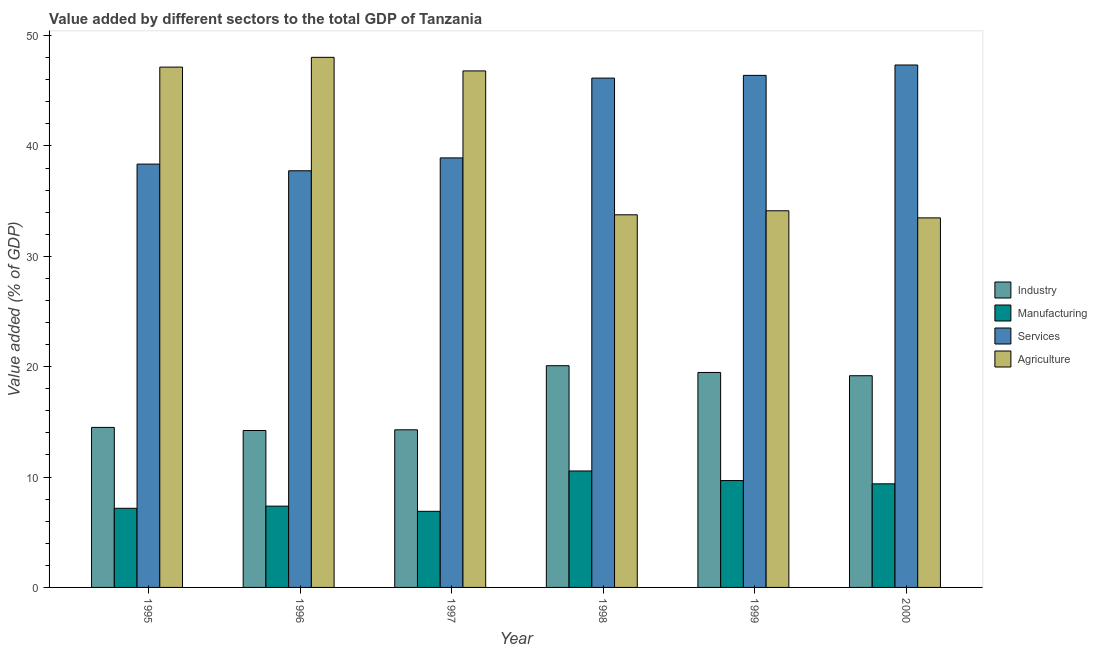How many bars are there on the 3rd tick from the left?
Your response must be concise. 4. What is the label of the 5th group of bars from the left?
Your answer should be very brief. 1999. What is the value added by industrial sector in 1999?
Your answer should be compact. 19.48. Across all years, what is the maximum value added by manufacturing sector?
Keep it short and to the point. 10.55. Across all years, what is the minimum value added by manufacturing sector?
Your answer should be compact. 6.9. In which year was the value added by industrial sector maximum?
Keep it short and to the point. 1998. In which year was the value added by services sector minimum?
Your response must be concise. 1996. What is the total value added by industrial sector in the graph?
Keep it short and to the point. 101.75. What is the difference between the value added by manufacturing sector in 1998 and that in 1999?
Provide a short and direct response. 0.87. What is the difference between the value added by services sector in 1995 and the value added by manufacturing sector in 1997?
Your response must be concise. -0.56. What is the average value added by agricultural sector per year?
Your answer should be very brief. 40.56. In the year 1999, what is the difference between the value added by services sector and value added by manufacturing sector?
Your answer should be compact. 0. In how many years, is the value added by services sector greater than 34 %?
Give a very brief answer. 6. What is the ratio of the value added by agricultural sector in 1999 to that in 2000?
Provide a succinct answer. 1.02. Is the value added by manufacturing sector in 1998 less than that in 2000?
Provide a succinct answer. No. Is the difference between the value added by manufacturing sector in 1998 and 2000 greater than the difference between the value added by services sector in 1998 and 2000?
Your response must be concise. No. What is the difference between the highest and the second highest value added by services sector?
Provide a succinct answer. 0.94. What is the difference between the highest and the lowest value added by services sector?
Provide a succinct answer. 9.58. Is the sum of the value added by manufacturing sector in 1997 and 1999 greater than the maximum value added by industrial sector across all years?
Make the answer very short. Yes. What does the 3rd bar from the left in 1999 represents?
Offer a terse response. Services. What does the 3rd bar from the right in 2000 represents?
Offer a terse response. Manufacturing. Is it the case that in every year, the sum of the value added by industrial sector and value added by manufacturing sector is greater than the value added by services sector?
Offer a very short reply. No. Are the values on the major ticks of Y-axis written in scientific E-notation?
Your response must be concise. No. Does the graph contain any zero values?
Your answer should be very brief. No. How many legend labels are there?
Provide a succinct answer. 4. What is the title of the graph?
Make the answer very short. Value added by different sectors to the total GDP of Tanzania. What is the label or title of the Y-axis?
Provide a succinct answer. Value added (% of GDP). What is the Value added (% of GDP) in Industry in 1995?
Offer a terse response. 14.5. What is the Value added (% of GDP) in Manufacturing in 1995?
Ensure brevity in your answer.  7.17. What is the Value added (% of GDP) of Services in 1995?
Your answer should be compact. 38.36. What is the Value added (% of GDP) in Agriculture in 1995?
Provide a short and direct response. 47.14. What is the Value added (% of GDP) of Industry in 1996?
Your answer should be very brief. 14.22. What is the Value added (% of GDP) in Manufacturing in 1996?
Your response must be concise. 7.37. What is the Value added (% of GDP) of Services in 1996?
Keep it short and to the point. 37.75. What is the Value added (% of GDP) of Agriculture in 1996?
Your answer should be compact. 48.03. What is the Value added (% of GDP) in Industry in 1997?
Your response must be concise. 14.28. What is the Value added (% of GDP) of Manufacturing in 1997?
Your answer should be very brief. 6.9. What is the Value added (% of GDP) in Services in 1997?
Ensure brevity in your answer.  38.92. What is the Value added (% of GDP) in Agriculture in 1997?
Provide a short and direct response. 46.8. What is the Value added (% of GDP) of Industry in 1998?
Make the answer very short. 20.09. What is the Value added (% of GDP) in Manufacturing in 1998?
Provide a short and direct response. 10.55. What is the Value added (% of GDP) in Services in 1998?
Keep it short and to the point. 46.15. What is the Value added (% of GDP) of Agriculture in 1998?
Provide a succinct answer. 33.76. What is the Value added (% of GDP) of Industry in 1999?
Provide a short and direct response. 19.48. What is the Value added (% of GDP) of Manufacturing in 1999?
Offer a very short reply. 9.68. What is the Value added (% of GDP) of Services in 1999?
Offer a terse response. 46.39. What is the Value added (% of GDP) of Agriculture in 1999?
Offer a very short reply. 34.13. What is the Value added (% of GDP) of Industry in 2000?
Offer a very short reply. 19.18. What is the Value added (% of GDP) in Manufacturing in 2000?
Ensure brevity in your answer.  9.39. What is the Value added (% of GDP) of Services in 2000?
Offer a very short reply. 47.34. What is the Value added (% of GDP) of Agriculture in 2000?
Offer a very short reply. 33.48. Across all years, what is the maximum Value added (% of GDP) of Industry?
Ensure brevity in your answer.  20.09. Across all years, what is the maximum Value added (% of GDP) of Manufacturing?
Give a very brief answer. 10.55. Across all years, what is the maximum Value added (% of GDP) of Services?
Your response must be concise. 47.34. Across all years, what is the maximum Value added (% of GDP) of Agriculture?
Keep it short and to the point. 48.03. Across all years, what is the minimum Value added (% of GDP) in Industry?
Provide a short and direct response. 14.22. Across all years, what is the minimum Value added (% of GDP) in Manufacturing?
Keep it short and to the point. 6.9. Across all years, what is the minimum Value added (% of GDP) in Services?
Keep it short and to the point. 37.75. Across all years, what is the minimum Value added (% of GDP) of Agriculture?
Ensure brevity in your answer.  33.48. What is the total Value added (% of GDP) of Industry in the graph?
Provide a short and direct response. 101.75. What is the total Value added (% of GDP) of Manufacturing in the graph?
Ensure brevity in your answer.  51.06. What is the total Value added (% of GDP) of Services in the graph?
Your answer should be compact. 254.91. What is the total Value added (% of GDP) of Agriculture in the graph?
Provide a short and direct response. 243.35. What is the difference between the Value added (% of GDP) of Industry in 1995 and that in 1996?
Give a very brief answer. 0.28. What is the difference between the Value added (% of GDP) in Manufacturing in 1995 and that in 1996?
Keep it short and to the point. -0.2. What is the difference between the Value added (% of GDP) of Services in 1995 and that in 1996?
Ensure brevity in your answer.  0.6. What is the difference between the Value added (% of GDP) of Agriculture in 1995 and that in 1996?
Your answer should be compact. -0.89. What is the difference between the Value added (% of GDP) of Industry in 1995 and that in 1997?
Provide a succinct answer. 0.22. What is the difference between the Value added (% of GDP) in Manufacturing in 1995 and that in 1997?
Make the answer very short. 0.27. What is the difference between the Value added (% of GDP) in Services in 1995 and that in 1997?
Make the answer very short. -0.56. What is the difference between the Value added (% of GDP) of Agriculture in 1995 and that in 1997?
Keep it short and to the point. 0.34. What is the difference between the Value added (% of GDP) of Industry in 1995 and that in 1998?
Offer a very short reply. -5.59. What is the difference between the Value added (% of GDP) of Manufacturing in 1995 and that in 1998?
Offer a terse response. -3.38. What is the difference between the Value added (% of GDP) in Services in 1995 and that in 1998?
Make the answer very short. -7.79. What is the difference between the Value added (% of GDP) in Agriculture in 1995 and that in 1998?
Provide a succinct answer. 13.38. What is the difference between the Value added (% of GDP) of Industry in 1995 and that in 1999?
Keep it short and to the point. -4.98. What is the difference between the Value added (% of GDP) in Manufacturing in 1995 and that in 1999?
Your response must be concise. -2.51. What is the difference between the Value added (% of GDP) in Services in 1995 and that in 1999?
Provide a succinct answer. -8.04. What is the difference between the Value added (% of GDP) in Agriculture in 1995 and that in 1999?
Provide a succinct answer. 13.02. What is the difference between the Value added (% of GDP) in Industry in 1995 and that in 2000?
Keep it short and to the point. -4.68. What is the difference between the Value added (% of GDP) of Manufacturing in 1995 and that in 2000?
Provide a succinct answer. -2.22. What is the difference between the Value added (% of GDP) in Services in 1995 and that in 2000?
Ensure brevity in your answer.  -8.98. What is the difference between the Value added (% of GDP) of Agriculture in 1995 and that in 2000?
Offer a terse response. 13.66. What is the difference between the Value added (% of GDP) of Industry in 1996 and that in 1997?
Keep it short and to the point. -0.06. What is the difference between the Value added (% of GDP) of Manufacturing in 1996 and that in 1997?
Offer a terse response. 0.47. What is the difference between the Value added (% of GDP) in Services in 1996 and that in 1997?
Ensure brevity in your answer.  -1.17. What is the difference between the Value added (% of GDP) in Agriculture in 1996 and that in 1997?
Your answer should be compact. 1.23. What is the difference between the Value added (% of GDP) of Industry in 1996 and that in 1998?
Offer a very short reply. -5.87. What is the difference between the Value added (% of GDP) in Manufacturing in 1996 and that in 1998?
Make the answer very short. -3.19. What is the difference between the Value added (% of GDP) of Services in 1996 and that in 1998?
Offer a very short reply. -8.4. What is the difference between the Value added (% of GDP) of Agriculture in 1996 and that in 1998?
Offer a very short reply. 14.27. What is the difference between the Value added (% of GDP) in Industry in 1996 and that in 1999?
Provide a short and direct response. -5.26. What is the difference between the Value added (% of GDP) in Manufacturing in 1996 and that in 1999?
Provide a succinct answer. -2.32. What is the difference between the Value added (% of GDP) in Services in 1996 and that in 1999?
Your response must be concise. -8.64. What is the difference between the Value added (% of GDP) in Agriculture in 1996 and that in 1999?
Provide a succinct answer. 13.9. What is the difference between the Value added (% of GDP) of Industry in 1996 and that in 2000?
Provide a short and direct response. -4.96. What is the difference between the Value added (% of GDP) in Manufacturing in 1996 and that in 2000?
Make the answer very short. -2.02. What is the difference between the Value added (% of GDP) in Services in 1996 and that in 2000?
Your response must be concise. -9.58. What is the difference between the Value added (% of GDP) in Agriculture in 1996 and that in 2000?
Offer a terse response. 14.55. What is the difference between the Value added (% of GDP) of Industry in 1997 and that in 1998?
Your answer should be compact. -5.81. What is the difference between the Value added (% of GDP) of Manufacturing in 1997 and that in 1998?
Provide a succinct answer. -3.66. What is the difference between the Value added (% of GDP) of Services in 1997 and that in 1998?
Provide a succinct answer. -7.23. What is the difference between the Value added (% of GDP) in Agriculture in 1997 and that in 1998?
Your response must be concise. 13.04. What is the difference between the Value added (% of GDP) of Industry in 1997 and that in 1999?
Offer a terse response. -5.2. What is the difference between the Value added (% of GDP) of Manufacturing in 1997 and that in 1999?
Keep it short and to the point. -2.79. What is the difference between the Value added (% of GDP) in Services in 1997 and that in 1999?
Keep it short and to the point. -7.48. What is the difference between the Value added (% of GDP) in Agriculture in 1997 and that in 1999?
Your answer should be very brief. 12.67. What is the difference between the Value added (% of GDP) in Industry in 1997 and that in 2000?
Keep it short and to the point. -4.9. What is the difference between the Value added (% of GDP) in Manufacturing in 1997 and that in 2000?
Make the answer very short. -2.49. What is the difference between the Value added (% of GDP) of Services in 1997 and that in 2000?
Provide a short and direct response. -8.42. What is the difference between the Value added (% of GDP) in Agriculture in 1997 and that in 2000?
Your answer should be very brief. 13.32. What is the difference between the Value added (% of GDP) of Industry in 1998 and that in 1999?
Ensure brevity in your answer.  0.61. What is the difference between the Value added (% of GDP) in Manufacturing in 1998 and that in 1999?
Your answer should be very brief. 0.87. What is the difference between the Value added (% of GDP) in Services in 1998 and that in 1999?
Provide a short and direct response. -0.25. What is the difference between the Value added (% of GDP) in Agriculture in 1998 and that in 1999?
Keep it short and to the point. -0.36. What is the difference between the Value added (% of GDP) in Industry in 1998 and that in 2000?
Provide a succinct answer. 0.91. What is the difference between the Value added (% of GDP) in Manufacturing in 1998 and that in 2000?
Provide a succinct answer. 1.17. What is the difference between the Value added (% of GDP) of Services in 1998 and that in 2000?
Keep it short and to the point. -1.19. What is the difference between the Value added (% of GDP) of Agriculture in 1998 and that in 2000?
Make the answer very short. 0.28. What is the difference between the Value added (% of GDP) in Industry in 1999 and that in 2000?
Your answer should be very brief. 0.3. What is the difference between the Value added (% of GDP) of Manufacturing in 1999 and that in 2000?
Your response must be concise. 0.3. What is the difference between the Value added (% of GDP) in Services in 1999 and that in 2000?
Offer a very short reply. -0.94. What is the difference between the Value added (% of GDP) of Agriculture in 1999 and that in 2000?
Provide a short and direct response. 0.65. What is the difference between the Value added (% of GDP) of Industry in 1995 and the Value added (% of GDP) of Manufacturing in 1996?
Your answer should be compact. 7.13. What is the difference between the Value added (% of GDP) of Industry in 1995 and the Value added (% of GDP) of Services in 1996?
Your answer should be very brief. -23.25. What is the difference between the Value added (% of GDP) of Industry in 1995 and the Value added (% of GDP) of Agriculture in 1996?
Keep it short and to the point. -33.53. What is the difference between the Value added (% of GDP) of Manufacturing in 1995 and the Value added (% of GDP) of Services in 1996?
Give a very brief answer. -30.58. What is the difference between the Value added (% of GDP) of Manufacturing in 1995 and the Value added (% of GDP) of Agriculture in 1996?
Your response must be concise. -40.86. What is the difference between the Value added (% of GDP) of Services in 1995 and the Value added (% of GDP) of Agriculture in 1996?
Offer a very short reply. -9.67. What is the difference between the Value added (% of GDP) of Industry in 1995 and the Value added (% of GDP) of Manufacturing in 1997?
Offer a very short reply. 7.6. What is the difference between the Value added (% of GDP) in Industry in 1995 and the Value added (% of GDP) in Services in 1997?
Your answer should be compact. -24.42. What is the difference between the Value added (% of GDP) in Industry in 1995 and the Value added (% of GDP) in Agriculture in 1997?
Offer a terse response. -32.3. What is the difference between the Value added (% of GDP) in Manufacturing in 1995 and the Value added (% of GDP) in Services in 1997?
Your response must be concise. -31.75. What is the difference between the Value added (% of GDP) of Manufacturing in 1995 and the Value added (% of GDP) of Agriculture in 1997?
Your response must be concise. -39.63. What is the difference between the Value added (% of GDP) of Services in 1995 and the Value added (% of GDP) of Agriculture in 1997?
Offer a very short reply. -8.44. What is the difference between the Value added (% of GDP) of Industry in 1995 and the Value added (% of GDP) of Manufacturing in 1998?
Offer a very short reply. 3.95. What is the difference between the Value added (% of GDP) of Industry in 1995 and the Value added (% of GDP) of Services in 1998?
Provide a succinct answer. -31.65. What is the difference between the Value added (% of GDP) of Industry in 1995 and the Value added (% of GDP) of Agriculture in 1998?
Your response must be concise. -19.26. What is the difference between the Value added (% of GDP) in Manufacturing in 1995 and the Value added (% of GDP) in Services in 1998?
Your answer should be compact. -38.98. What is the difference between the Value added (% of GDP) of Manufacturing in 1995 and the Value added (% of GDP) of Agriculture in 1998?
Keep it short and to the point. -26.59. What is the difference between the Value added (% of GDP) of Services in 1995 and the Value added (% of GDP) of Agriculture in 1998?
Give a very brief answer. 4.59. What is the difference between the Value added (% of GDP) of Industry in 1995 and the Value added (% of GDP) of Manufacturing in 1999?
Make the answer very short. 4.82. What is the difference between the Value added (% of GDP) in Industry in 1995 and the Value added (% of GDP) in Services in 1999?
Keep it short and to the point. -31.9. What is the difference between the Value added (% of GDP) of Industry in 1995 and the Value added (% of GDP) of Agriculture in 1999?
Your answer should be very brief. -19.63. What is the difference between the Value added (% of GDP) in Manufacturing in 1995 and the Value added (% of GDP) in Services in 1999?
Offer a very short reply. -39.22. What is the difference between the Value added (% of GDP) in Manufacturing in 1995 and the Value added (% of GDP) in Agriculture in 1999?
Offer a terse response. -26.96. What is the difference between the Value added (% of GDP) in Services in 1995 and the Value added (% of GDP) in Agriculture in 1999?
Your response must be concise. 4.23. What is the difference between the Value added (% of GDP) of Industry in 1995 and the Value added (% of GDP) of Manufacturing in 2000?
Make the answer very short. 5.11. What is the difference between the Value added (% of GDP) in Industry in 1995 and the Value added (% of GDP) in Services in 2000?
Offer a terse response. -32.84. What is the difference between the Value added (% of GDP) of Industry in 1995 and the Value added (% of GDP) of Agriculture in 2000?
Offer a terse response. -18.98. What is the difference between the Value added (% of GDP) of Manufacturing in 1995 and the Value added (% of GDP) of Services in 2000?
Offer a very short reply. -40.17. What is the difference between the Value added (% of GDP) in Manufacturing in 1995 and the Value added (% of GDP) in Agriculture in 2000?
Make the answer very short. -26.31. What is the difference between the Value added (% of GDP) in Services in 1995 and the Value added (% of GDP) in Agriculture in 2000?
Your answer should be very brief. 4.87. What is the difference between the Value added (% of GDP) of Industry in 1996 and the Value added (% of GDP) of Manufacturing in 1997?
Your answer should be compact. 7.32. What is the difference between the Value added (% of GDP) of Industry in 1996 and the Value added (% of GDP) of Services in 1997?
Provide a succinct answer. -24.7. What is the difference between the Value added (% of GDP) in Industry in 1996 and the Value added (% of GDP) in Agriculture in 1997?
Ensure brevity in your answer.  -32.58. What is the difference between the Value added (% of GDP) of Manufacturing in 1996 and the Value added (% of GDP) of Services in 1997?
Provide a short and direct response. -31.55. What is the difference between the Value added (% of GDP) of Manufacturing in 1996 and the Value added (% of GDP) of Agriculture in 1997?
Provide a succinct answer. -39.43. What is the difference between the Value added (% of GDP) in Services in 1996 and the Value added (% of GDP) in Agriculture in 1997?
Provide a succinct answer. -9.05. What is the difference between the Value added (% of GDP) of Industry in 1996 and the Value added (% of GDP) of Manufacturing in 1998?
Offer a terse response. 3.67. What is the difference between the Value added (% of GDP) of Industry in 1996 and the Value added (% of GDP) of Services in 1998?
Keep it short and to the point. -31.93. What is the difference between the Value added (% of GDP) in Industry in 1996 and the Value added (% of GDP) in Agriculture in 1998?
Offer a terse response. -19.54. What is the difference between the Value added (% of GDP) of Manufacturing in 1996 and the Value added (% of GDP) of Services in 1998?
Make the answer very short. -38.78. What is the difference between the Value added (% of GDP) of Manufacturing in 1996 and the Value added (% of GDP) of Agriculture in 1998?
Your answer should be very brief. -26.4. What is the difference between the Value added (% of GDP) of Services in 1996 and the Value added (% of GDP) of Agriculture in 1998?
Keep it short and to the point. 3.99. What is the difference between the Value added (% of GDP) of Industry in 1996 and the Value added (% of GDP) of Manufacturing in 1999?
Give a very brief answer. 4.53. What is the difference between the Value added (% of GDP) of Industry in 1996 and the Value added (% of GDP) of Services in 1999?
Your response must be concise. -32.18. What is the difference between the Value added (% of GDP) of Industry in 1996 and the Value added (% of GDP) of Agriculture in 1999?
Provide a succinct answer. -19.91. What is the difference between the Value added (% of GDP) of Manufacturing in 1996 and the Value added (% of GDP) of Services in 1999?
Keep it short and to the point. -39.03. What is the difference between the Value added (% of GDP) in Manufacturing in 1996 and the Value added (% of GDP) in Agriculture in 1999?
Keep it short and to the point. -26.76. What is the difference between the Value added (% of GDP) in Services in 1996 and the Value added (% of GDP) in Agriculture in 1999?
Provide a short and direct response. 3.62. What is the difference between the Value added (% of GDP) of Industry in 1996 and the Value added (% of GDP) of Manufacturing in 2000?
Provide a succinct answer. 4.83. What is the difference between the Value added (% of GDP) in Industry in 1996 and the Value added (% of GDP) in Services in 2000?
Keep it short and to the point. -33.12. What is the difference between the Value added (% of GDP) in Industry in 1996 and the Value added (% of GDP) in Agriculture in 2000?
Provide a succinct answer. -19.26. What is the difference between the Value added (% of GDP) in Manufacturing in 1996 and the Value added (% of GDP) in Services in 2000?
Ensure brevity in your answer.  -39.97. What is the difference between the Value added (% of GDP) of Manufacturing in 1996 and the Value added (% of GDP) of Agriculture in 2000?
Offer a very short reply. -26.12. What is the difference between the Value added (% of GDP) of Services in 1996 and the Value added (% of GDP) of Agriculture in 2000?
Give a very brief answer. 4.27. What is the difference between the Value added (% of GDP) of Industry in 1997 and the Value added (% of GDP) of Manufacturing in 1998?
Provide a succinct answer. 3.73. What is the difference between the Value added (% of GDP) of Industry in 1997 and the Value added (% of GDP) of Services in 1998?
Offer a terse response. -31.87. What is the difference between the Value added (% of GDP) of Industry in 1997 and the Value added (% of GDP) of Agriculture in 1998?
Keep it short and to the point. -19.48. What is the difference between the Value added (% of GDP) of Manufacturing in 1997 and the Value added (% of GDP) of Services in 1998?
Offer a terse response. -39.25. What is the difference between the Value added (% of GDP) in Manufacturing in 1997 and the Value added (% of GDP) in Agriculture in 1998?
Provide a short and direct response. -26.87. What is the difference between the Value added (% of GDP) of Services in 1997 and the Value added (% of GDP) of Agriculture in 1998?
Offer a very short reply. 5.16. What is the difference between the Value added (% of GDP) in Industry in 1997 and the Value added (% of GDP) in Manufacturing in 1999?
Your answer should be compact. 4.6. What is the difference between the Value added (% of GDP) of Industry in 1997 and the Value added (% of GDP) of Services in 1999?
Your response must be concise. -32.11. What is the difference between the Value added (% of GDP) of Industry in 1997 and the Value added (% of GDP) of Agriculture in 1999?
Your answer should be compact. -19.85. What is the difference between the Value added (% of GDP) of Manufacturing in 1997 and the Value added (% of GDP) of Services in 1999?
Offer a terse response. -39.5. What is the difference between the Value added (% of GDP) of Manufacturing in 1997 and the Value added (% of GDP) of Agriculture in 1999?
Your answer should be compact. -27.23. What is the difference between the Value added (% of GDP) in Services in 1997 and the Value added (% of GDP) in Agriculture in 1999?
Your answer should be compact. 4.79. What is the difference between the Value added (% of GDP) of Industry in 1997 and the Value added (% of GDP) of Manufacturing in 2000?
Provide a succinct answer. 4.89. What is the difference between the Value added (% of GDP) in Industry in 1997 and the Value added (% of GDP) in Services in 2000?
Keep it short and to the point. -33.05. What is the difference between the Value added (% of GDP) in Industry in 1997 and the Value added (% of GDP) in Agriculture in 2000?
Your answer should be compact. -19.2. What is the difference between the Value added (% of GDP) of Manufacturing in 1997 and the Value added (% of GDP) of Services in 2000?
Give a very brief answer. -40.44. What is the difference between the Value added (% of GDP) of Manufacturing in 1997 and the Value added (% of GDP) of Agriculture in 2000?
Provide a short and direct response. -26.59. What is the difference between the Value added (% of GDP) in Services in 1997 and the Value added (% of GDP) in Agriculture in 2000?
Give a very brief answer. 5.44. What is the difference between the Value added (% of GDP) in Industry in 1998 and the Value added (% of GDP) in Manufacturing in 1999?
Your answer should be very brief. 10.4. What is the difference between the Value added (% of GDP) in Industry in 1998 and the Value added (% of GDP) in Services in 1999?
Ensure brevity in your answer.  -26.31. What is the difference between the Value added (% of GDP) of Industry in 1998 and the Value added (% of GDP) of Agriculture in 1999?
Your answer should be compact. -14.04. What is the difference between the Value added (% of GDP) in Manufacturing in 1998 and the Value added (% of GDP) in Services in 1999?
Give a very brief answer. -35.84. What is the difference between the Value added (% of GDP) of Manufacturing in 1998 and the Value added (% of GDP) of Agriculture in 1999?
Provide a succinct answer. -23.58. What is the difference between the Value added (% of GDP) in Services in 1998 and the Value added (% of GDP) in Agriculture in 1999?
Give a very brief answer. 12.02. What is the difference between the Value added (% of GDP) of Industry in 1998 and the Value added (% of GDP) of Manufacturing in 2000?
Your answer should be compact. 10.7. What is the difference between the Value added (% of GDP) of Industry in 1998 and the Value added (% of GDP) of Services in 2000?
Make the answer very short. -27.25. What is the difference between the Value added (% of GDP) of Industry in 1998 and the Value added (% of GDP) of Agriculture in 2000?
Your answer should be compact. -13.39. What is the difference between the Value added (% of GDP) of Manufacturing in 1998 and the Value added (% of GDP) of Services in 2000?
Your answer should be compact. -36.78. What is the difference between the Value added (% of GDP) of Manufacturing in 1998 and the Value added (% of GDP) of Agriculture in 2000?
Offer a terse response. -22.93. What is the difference between the Value added (% of GDP) in Services in 1998 and the Value added (% of GDP) in Agriculture in 2000?
Offer a very short reply. 12.67. What is the difference between the Value added (% of GDP) in Industry in 1999 and the Value added (% of GDP) in Manufacturing in 2000?
Offer a terse response. 10.09. What is the difference between the Value added (% of GDP) of Industry in 1999 and the Value added (% of GDP) of Services in 2000?
Your response must be concise. -27.86. What is the difference between the Value added (% of GDP) in Industry in 1999 and the Value added (% of GDP) in Agriculture in 2000?
Your answer should be very brief. -14. What is the difference between the Value added (% of GDP) in Manufacturing in 1999 and the Value added (% of GDP) in Services in 2000?
Your response must be concise. -37.65. What is the difference between the Value added (% of GDP) in Manufacturing in 1999 and the Value added (% of GDP) in Agriculture in 2000?
Give a very brief answer. -23.8. What is the difference between the Value added (% of GDP) in Services in 1999 and the Value added (% of GDP) in Agriculture in 2000?
Keep it short and to the point. 12.91. What is the average Value added (% of GDP) of Industry per year?
Provide a succinct answer. 16.96. What is the average Value added (% of GDP) in Manufacturing per year?
Your answer should be very brief. 8.51. What is the average Value added (% of GDP) of Services per year?
Your answer should be very brief. 42.48. What is the average Value added (% of GDP) of Agriculture per year?
Your response must be concise. 40.56. In the year 1995, what is the difference between the Value added (% of GDP) in Industry and Value added (% of GDP) in Manufacturing?
Give a very brief answer. 7.33. In the year 1995, what is the difference between the Value added (% of GDP) in Industry and Value added (% of GDP) in Services?
Keep it short and to the point. -23.86. In the year 1995, what is the difference between the Value added (% of GDP) of Industry and Value added (% of GDP) of Agriculture?
Your answer should be compact. -32.65. In the year 1995, what is the difference between the Value added (% of GDP) of Manufacturing and Value added (% of GDP) of Services?
Offer a terse response. -31.19. In the year 1995, what is the difference between the Value added (% of GDP) in Manufacturing and Value added (% of GDP) in Agriculture?
Keep it short and to the point. -39.97. In the year 1995, what is the difference between the Value added (% of GDP) in Services and Value added (% of GDP) in Agriculture?
Offer a very short reply. -8.79. In the year 1996, what is the difference between the Value added (% of GDP) of Industry and Value added (% of GDP) of Manufacturing?
Ensure brevity in your answer.  6.85. In the year 1996, what is the difference between the Value added (% of GDP) of Industry and Value added (% of GDP) of Services?
Give a very brief answer. -23.53. In the year 1996, what is the difference between the Value added (% of GDP) in Industry and Value added (% of GDP) in Agriculture?
Provide a short and direct response. -33.81. In the year 1996, what is the difference between the Value added (% of GDP) in Manufacturing and Value added (% of GDP) in Services?
Your response must be concise. -30.39. In the year 1996, what is the difference between the Value added (% of GDP) in Manufacturing and Value added (% of GDP) in Agriculture?
Make the answer very short. -40.66. In the year 1996, what is the difference between the Value added (% of GDP) of Services and Value added (% of GDP) of Agriculture?
Keep it short and to the point. -10.28. In the year 1997, what is the difference between the Value added (% of GDP) in Industry and Value added (% of GDP) in Manufacturing?
Keep it short and to the point. 7.39. In the year 1997, what is the difference between the Value added (% of GDP) of Industry and Value added (% of GDP) of Services?
Your response must be concise. -24.64. In the year 1997, what is the difference between the Value added (% of GDP) of Industry and Value added (% of GDP) of Agriculture?
Provide a short and direct response. -32.52. In the year 1997, what is the difference between the Value added (% of GDP) in Manufacturing and Value added (% of GDP) in Services?
Your answer should be very brief. -32.02. In the year 1997, what is the difference between the Value added (% of GDP) of Manufacturing and Value added (% of GDP) of Agriculture?
Ensure brevity in your answer.  -39.9. In the year 1997, what is the difference between the Value added (% of GDP) in Services and Value added (% of GDP) in Agriculture?
Provide a succinct answer. -7.88. In the year 1998, what is the difference between the Value added (% of GDP) of Industry and Value added (% of GDP) of Manufacturing?
Offer a very short reply. 9.54. In the year 1998, what is the difference between the Value added (% of GDP) of Industry and Value added (% of GDP) of Services?
Give a very brief answer. -26.06. In the year 1998, what is the difference between the Value added (% of GDP) in Industry and Value added (% of GDP) in Agriculture?
Offer a very short reply. -13.67. In the year 1998, what is the difference between the Value added (% of GDP) of Manufacturing and Value added (% of GDP) of Services?
Your answer should be compact. -35.6. In the year 1998, what is the difference between the Value added (% of GDP) of Manufacturing and Value added (% of GDP) of Agriculture?
Ensure brevity in your answer.  -23.21. In the year 1998, what is the difference between the Value added (% of GDP) of Services and Value added (% of GDP) of Agriculture?
Keep it short and to the point. 12.39. In the year 1999, what is the difference between the Value added (% of GDP) in Industry and Value added (% of GDP) in Manufacturing?
Offer a very short reply. 9.79. In the year 1999, what is the difference between the Value added (% of GDP) in Industry and Value added (% of GDP) in Services?
Ensure brevity in your answer.  -26.92. In the year 1999, what is the difference between the Value added (% of GDP) of Industry and Value added (% of GDP) of Agriculture?
Provide a short and direct response. -14.65. In the year 1999, what is the difference between the Value added (% of GDP) in Manufacturing and Value added (% of GDP) in Services?
Ensure brevity in your answer.  -36.71. In the year 1999, what is the difference between the Value added (% of GDP) in Manufacturing and Value added (% of GDP) in Agriculture?
Your answer should be compact. -24.44. In the year 1999, what is the difference between the Value added (% of GDP) in Services and Value added (% of GDP) in Agriculture?
Give a very brief answer. 12.27. In the year 2000, what is the difference between the Value added (% of GDP) in Industry and Value added (% of GDP) in Manufacturing?
Ensure brevity in your answer.  9.79. In the year 2000, what is the difference between the Value added (% of GDP) of Industry and Value added (% of GDP) of Services?
Provide a succinct answer. -28.16. In the year 2000, what is the difference between the Value added (% of GDP) of Industry and Value added (% of GDP) of Agriculture?
Your response must be concise. -14.3. In the year 2000, what is the difference between the Value added (% of GDP) of Manufacturing and Value added (% of GDP) of Services?
Keep it short and to the point. -37.95. In the year 2000, what is the difference between the Value added (% of GDP) in Manufacturing and Value added (% of GDP) in Agriculture?
Offer a terse response. -24.1. In the year 2000, what is the difference between the Value added (% of GDP) in Services and Value added (% of GDP) in Agriculture?
Offer a terse response. 13.85. What is the ratio of the Value added (% of GDP) in Industry in 1995 to that in 1996?
Your answer should be very brief. 1.02. What is the ratio of the Value added (% of GDP) in Manufacturing in 1995 to that in 1996?
Your answer should be compact. 0.97. What is the ratio of the Value added (% of GDP) of Agriculture in 1995 to that in 1996?
Keep it short and to the point. 0.98. What is the ratio of the Value added (% of GDP) of Industry in 1995 to that in 1997?
Give a very brief answer. 1.02. What is the ratio of the Value added (% of GDP) in Manufacturing in 1995 to that in 1997?
Keep it short and to the point. 1.04. What is the ratio of the Value added (% of GDP) in Services in 1995 to that in 1997?
Keep it short and to the point. 0.99. What is the ratio of the Value added (% of GDP) in Agriculture in 1995 to that in 1997?
Make the answer very short. 1.01. What is the ratio of the Value added (% of GDP) in Industry in 1995 to that in 1998?
Give a very brief answer. 0.72. What is the ratio of the Value added (% of GDP) of Manufacturing in 1995 to that in 1998?
Make the answer very short. 0.68. What is the ratio of the Value added (% of GDP) in Services in 1995 to that in 1998?
Ensure brevity in your answer.  0.83. What is the ratio of the Value added (% of GDP) in Agriculture in 1995 to that in 1998?
Ensure brevity in your answer.  1.4. What is the ratio of the Value added (% of GDP) of Industry in 1995 to that in 1999?
Provide a succinct answer. 0.74. What is the ratio of the Value added (% of GDP) of Manufacturing in 1995 to that in 1999?
Provide a short and direct response. 0.74. What is the ratio of the Value added (% of GDP) of Services in 1995 to that in 1999?
Give a very brief answer. 0.83. What is the ratio of the Value added (% of GDP) in Agriculture in 1995 to that in 1999?
Your answer should be very brief. 1.38. What is the ratio of the Value added (% of GDP) in Industry in 1995 to that in 2000?
Make the answer very short. 0.76. What is the ratio of the Value added (% of GDP) in Manufacturing in 1995 to that in 2000?
Make the answer very short. 0.76. What is the ratio of the Value added (% of GDP) in Services in 1995 to that in 2000?
Offer a terse response. 0.81. What is the ratio of the Value added (% of GDP) of Agriculture in 1995 to that in 2000?
Make the answer very short. 1.41. What is the ratio of the Value added (% of GDP) of Industry in 1996 to that in 1997?
Offer a terse response. 1. What is the ratio of the Value added (% of GDP) in Manufacturing in 1996 to that in 1997?
Give a very brief answer. 1.07. What is the ratio of the Value added (% of GDP) in Agriculture in 1996 to that in 1997?
Offer a terse response. 1.03. What is the ratio of the Value added (% of GDP) in Industry in 1996 to that in 1998?
Keep it short and to the point. 0.71. What is the ratio of the Value added (% of GDP) of Manufacturing in 1996 to that in 1998?
Offer a terse response. 0.7. What is the ratio of the Value added (% of GDP) of Services in 1996 to that in 1998?
Offer a terse response. 0.82. What is the ratio of the Value added (% of GDP) in Agriculture in 1996 to that in 1998?
Ensure brevity in your answer.  1.42. What is the ratio of the Value added (% of GDP) of Industry in 1996 to that in 1999?
Offer a terse response. 0.73. What is the ratio of the Value added (% of GDP) in Manufacturing in 1996 to that in 1999?
Offer a very short reply. 0.76. What is the ratio of the Value added (% of GDP) in Services in 1996 to that in 1999?
Provide a short and direct response. 0.81. What is the ratio of the Value added (% of GDP) of Agriculture in 1996 to that in 1999?
Keep it short and to the point. 1.41. What is the ratio of the Value added (% of GDP) in Industry in 1996 to that in 2000?
Your answer should be very brief. 0.74. What is the ratio of the Value added (% of GDP) of Manufacturing in 1996 to that in 2000?
Your answer should be very brief. 0.78. What is the ratio of the Value added (% of GDP) in Services in 1996 to that in 2000?
Offer a very short reply. 0.8. What is the ratio of the Value added (% of GDP) in Agriculture in 1996 to that in 2000?
Your response must be concise. 1.43. What is the ratio of the Value added (% of GDP) of Industry in 1997 to that in 1998?
Offer a terse response. 0.71. What is the ratio of the Value added (% of GDP) in Manufacturing in 1997 to that in 1998?
Your answer should be very brief. 0.65. What is the ratio of the Value added (% of GDP) in Services in 1997 to that in 1998?
Your answer should be very brief. 0.84. What is the ratio of the Value added (% of GDP) in Agriculture in 1997 to that in 1998?
Provide a short and direct response. 1.39. What is the ratio of the Value added (% of GDP) of Industry in 1997 to that in 1999?
Provide a short and direct response. 0.73. What is the ratio of the Value added (% of GDP) of Manufacturing in 1997 to that in 1999?
Offer a very short reply. 0.71. What is the ratio of the Value added (% of GDP) in Services in 1997 to that in 1999?
Your response must be concise. 0.84. What is the ratio of the Value added (% of GDP) of Agriculture in 1997 to that in 1999?
Your answer should be compact. 1.37. What is the ratio of the Value added (% of GDP) of Industry in 1997 to that in 2000?
Keep it short and to the point. 0.74. What is the ratio of the Value added (% of GDP) in Manufacturing in 1997 to that in 2000?
Keep it short and to the point. 0.73. What is the ratio of the Value added (% of GDP) of Services in 1997 to that in 2000?
Keep it short and to the point. 0.82. What is the ratio of the Value added (% of GDP) of Agriculture in 1997 to that in 2000?
Ensure brevity in your answer.  1.4. What is the ratio of the Value added (% of GDP) of Industry in 1998 to that in 1999?
Provide a succinct answer. 1.03. What is the ratio of the Value added (% of GDP) in Manufacturing in 1998 to that in 1999?
Ensure brevity in your answer.  1.09. What is the ratio of the Value added (% of GDP) of Agriculture in 1998 to that in 1999?
Ensure brevity in your answer.  0.99. What is the ratio of the Value added (% of GDP) of Industry in 1998 to that in 2000?
Make the answer very short. 1.05. What is the ratio of the Value added (% of GDP) of Manufacturing in 1998 to that in 2000?
Your response must be concise. 1.12. What is the ratio of the Value added (% of GDP) of Services in 1998 to that in 2000?
Give a very brief answer. 0.97. What is the ratio of the Value added (% of GDP) in Agriculture in 1998 to that in 2000?
Ensure brevity in your answer.  1.01. What is the ratio of the Value added (% of GDP) in Industry in 1999 to that in 2000?
Provide a short and direct response. 1.02. What is the ratio of the Value added (% of GDP) in Manufacturing in 1999 to that in 2000?
Your answer should be compact. 1.03. What is the ratio of the Value added (% of GDP) in Services in 1999 to that in 2000?
Give a very brief answer. 0.98. What is the ratio of the Value added (% of GDP) of Agriculture in 1999 to that in 2000?
Give a very brief answer. 1.02. What is the difference between the highest and the second highest Value added (% of GDP) in Industry?
Make the answer very short. 0.61. What is the difference between the highest and the second highest Value added (% of GDP) in Manufacturing?
Provide a short and direct response. 0.87. What is the difference between the highest and the second highest Value added (% of GDP) in Services?
Ensure brevity in your answer.  0.94. What is the difference between the highest and the second highest Value added (% of GDP) of Agriculture?
Your answer should be compact. 0.89. What is the difference between the highest and the lowest Value added (% of GDP) of Industry?
Offer a very short reply. 5.87. What is the difference between the highest and the lowest Value added (% of GDP) of Manufacturing?
Give a very brief answer. 3.66. What is the difference between the highest and the lowest Value added (% of GDP) of Services?
Provide a succinct answer. 9.58. What is the difference between the highest and the lowest Value added (% of GDP) of Agriculture?
Ensure brevity in your answer.  14.55. 